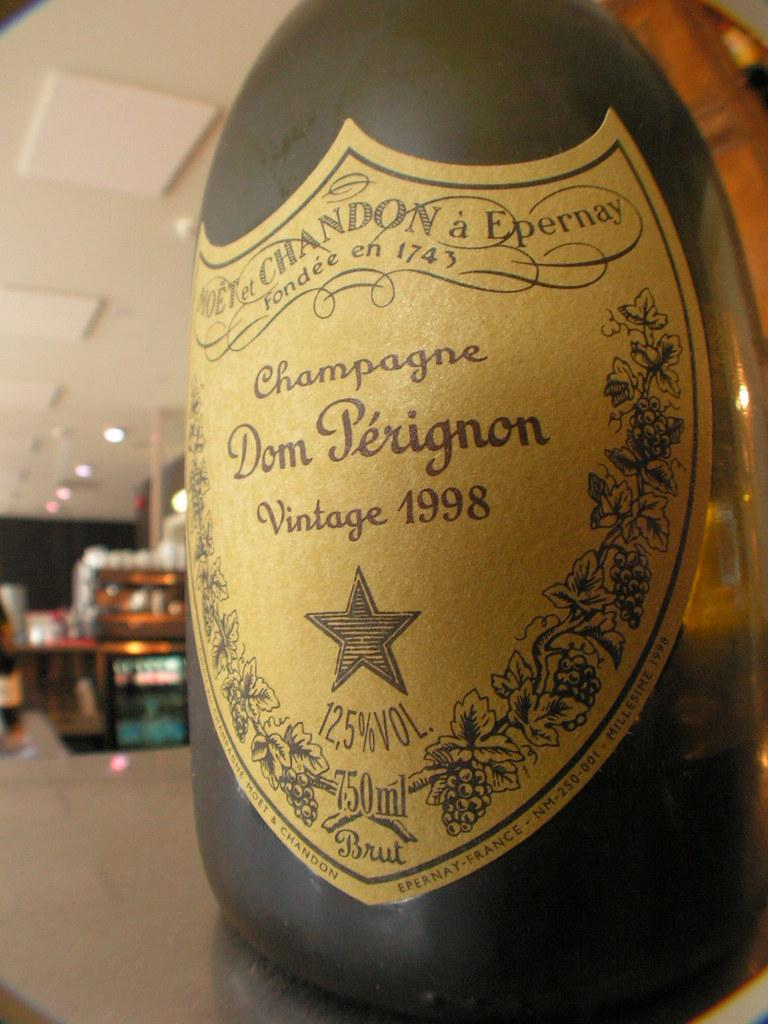<image>
Summarize the visual content of the image. a bottle of Champagne Dom Perignon Vintage 1998 